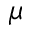Convert formula to latex. <formula><loc_0><loc_0><loc_500><loc_500>\mu</formula> 